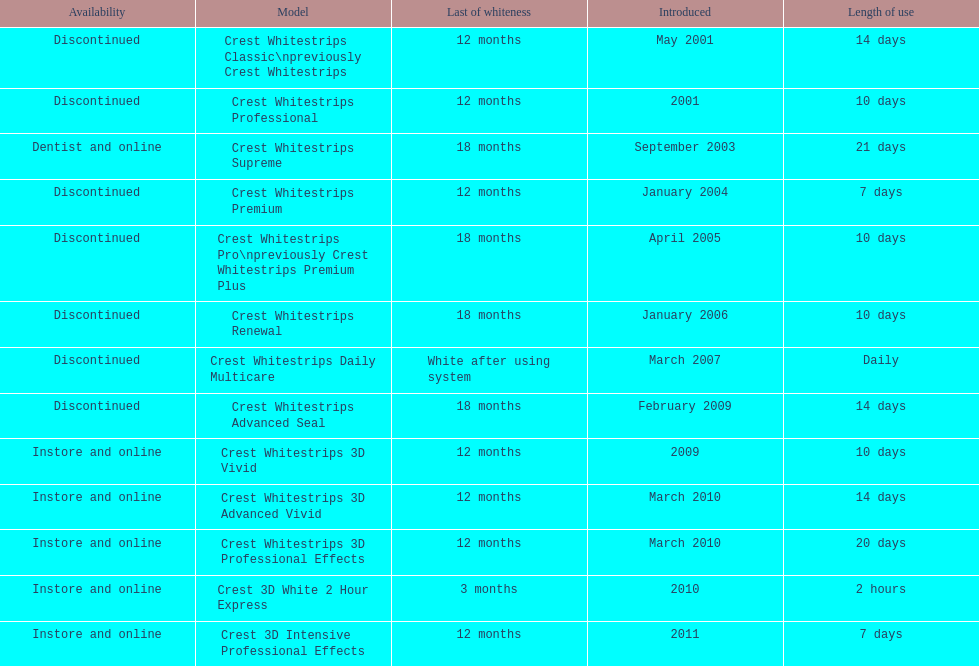How many models require less than a week of use? 2. 